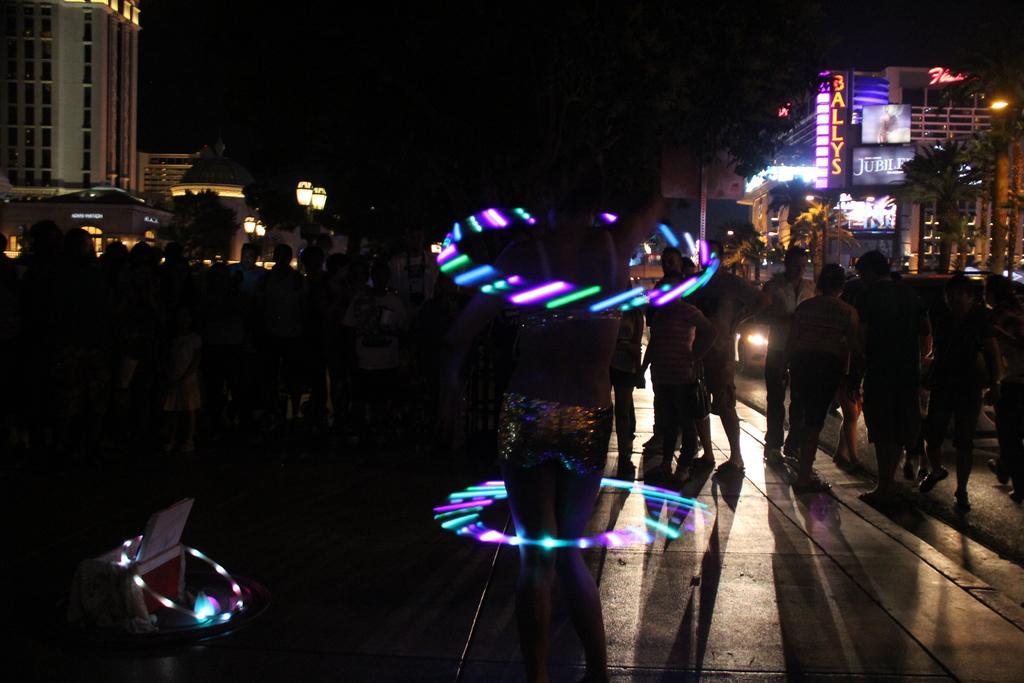Describe this image in one or two sentences. In this picture we can see a person is playing with light objects. In front of the person there is a group of people standing. Behind the people there is a vehicle, buildings, trees, poles with lights and on the buildings there are hoardings and a name board. Behind the buildings there is the dark background. 